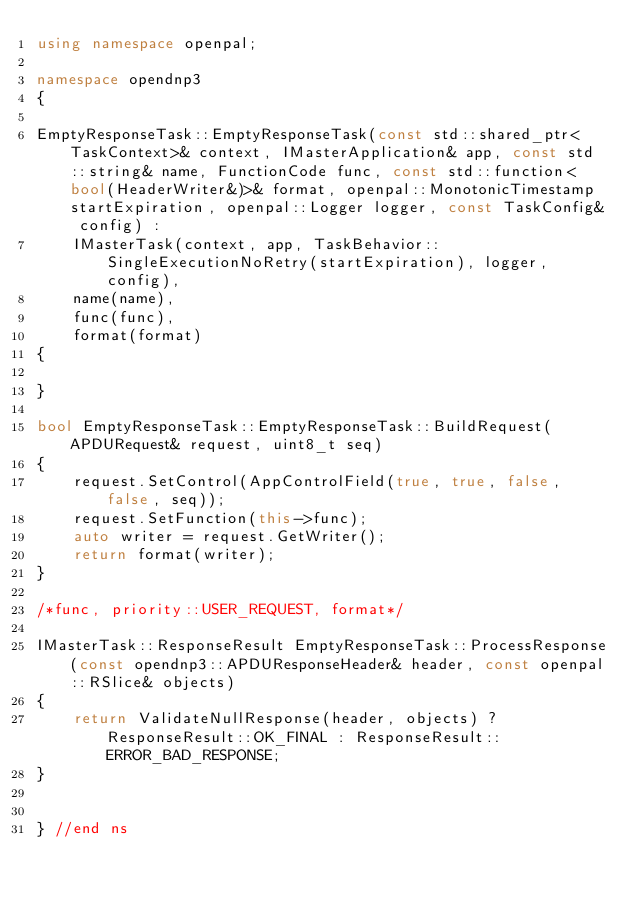<code> <loc_0><loc_0><loc_500><loc_500><_C++_>using namespace openpal;

namespace opendnp3
{

EmptyResponseTask::EmptyResponseTask(const std::shared_ptr<TaskContext>& context, IMasterApplication& app, const std::string& name, FunctionCode func, const std::function<bool(HeaderWriter&)>& format, openpal::MonotonicTimestamp startExpiration, openpal::Logger logger, const TaskConfig& config) :
	IMasterTask(context, app, TaskBehavior::SingleExecutionNoRetry(startExpiration), logger, config),
	name(name),
	func(func),
	format(format)
{

}

bool EmptyResponseTask::EmptyResponseTask::BuildRequest(APDURequest& request, uint8_t seq)
{
	request.SetControl(AppControlField(true, true, false, false, seq));
	request.SetFunction(this->func);
	auto writer = request.GetWriter();
	return format(writer);
}

/*func, priority::USER_REQUEST, format*/

IMasterTask::ResponseResult EmptyResponseTask::ProcessResponse(const opendnp3::APDUResponseHeader& header, const openpal::RSlice& objects)
{
	return ValidateNullResponse(header, objects) ? ResponseResult::OK_FINAL : ResponseResult::ERROR_BAD_RESPONSE;
}


} //end ns

</code> 